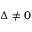<formula> <loc_0><loc_0><loc_500><loc_500>\Delta \neq 0</formula> 